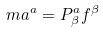<formula> <loc_0><loc_0><loc_500><loc_500>m a ^ { a } = P ^ { a } _ { \beta } f ^ { \beta }</formula> 